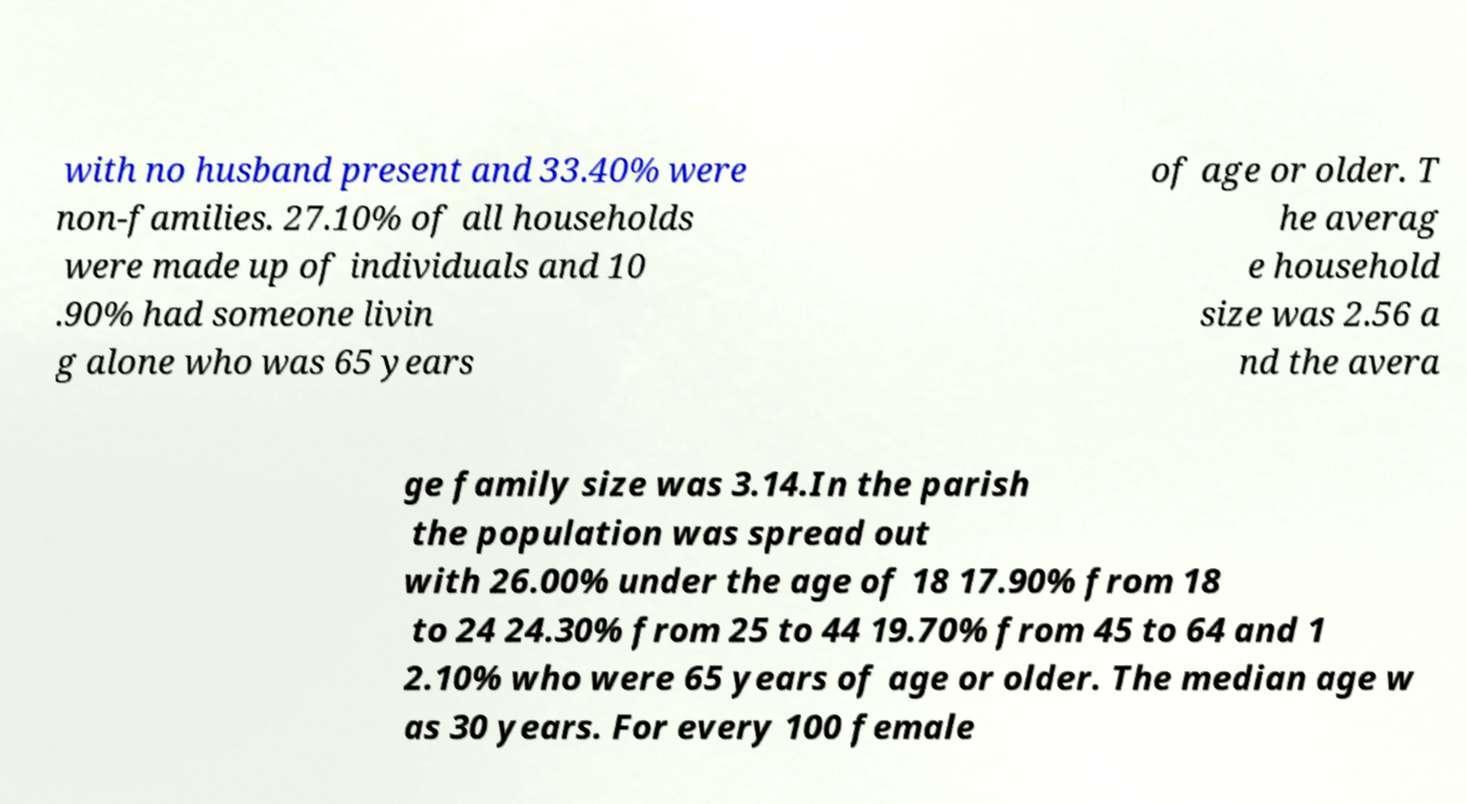For documentation purposes, I need the text within this image transcribed. Could you provide that? with no husband present and 33.40% were non-families. 27.10% of all households were made up of individuals and 10 .90% had someone livin g alone who was 65 years of age or older. T he averag e household size was 2.56 a nd the avera ge family size was 3.14.In the parish the population was spread out with 26.00% under the age of 18 17.90% from 18 to 24 24.30% from 25 to 44 19.70% from 45 to 64 and 1 2.10% who were 65 years of age or older. The median age w as 30 years. For every 100 female 